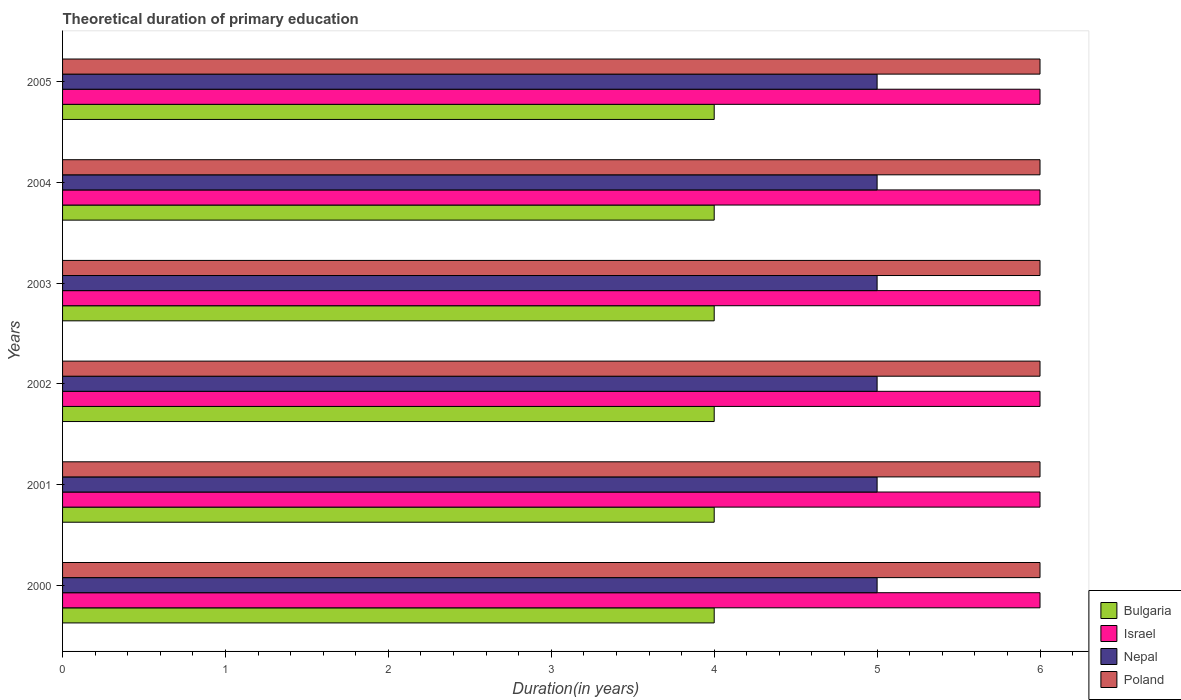How many different coloured bars are there?
Your response must be concise. 4. How many groups of bars are there?
Give a very brief answer. 6. What is the label of the 6th group of bars from the top?
Your response must be concise. 2000. In how many cases, is the number of bars for a given year not equal to the number of legend labels?
Keep it short and to the point. 0. What is the total theoretical duration of primary education in Bulgaria in 2004?
Give a very brief answer. 4. In which year was the total theoretical duration of primary education in Israel minimum?
Your response must be concise. 2000. What is the total total theoretical duration of primary education in Nepal in the graph?
Your answer should be compact. 30. What is the difference between the total theoretical duration of primary education in Israel in 2005 and the total theoretical duration of primary education in Bulgaria in 2001?
Provide a succinct answer. 2. What is the average total theoretical duration of primary education in Nepal per year?
Offer a very short reply. 5. What is the ratio of the total theoretical duration of primary education in Bulgaria in 2003 to that in 2004?
Make the answer very short. 1. Is the difference between the total theoretical duration of primary education in Poland in 2000 and 2005 greater than the difference between the total theoretical duration of primary education in Israel in 2000 and 2005?
Provide a succinct answer. No. What is the difference between the highest and the second highest total theoretical duration of primary education in Poland?
Offer a terse response. 0. What is the difference between the highest and the lowest total theoretical duration of primary education in Nepal?
Your answer should be compact. 0. In how many years, is the total theoretical duration of primary education in Nepal greater than the average total theoretical duration of primary education in Nepal taken over all years?
Your response must be concise. 0. What does the 3rd bar from the bottom in 2005 represents?
Make the answer very short. Nepal. Is it the case that in every year, the sum of the total theoretical duration of primary education in Bulgaria and total theoretical duration of primary education in Poland is greater than the total theoretical duration of primary education in Nepal?
Your answer should be very brief. Yes. Are all the bars in the graph horizontal?
Offer a very short reply. Yes. Does the graph contain any zero values?
Keep it short and to the point. No. Where does the legend appear in the graph?
Keep it short and to the point. Bottom right. How many legend labels are there?
Offer a terse response. 4. How are the legend labels stacked?
Give a very brief answer. Vertical. What is the title of the graph?
Your answer should be compact. Theoretical duration of primary education. What is the label or title of the X-axis?
Make the answer very short. Duration(in years). What is the Duration(in years) in Bulgaria in 2000?
Ensure brevity in your answer.  4. What is the Duration(in years) in Nepal in 2000?
Provide a short and direct response. 5. What is the Duration(in years) in Poland in 2001?
Offer a terse response. 6. What is the Duration(in years) of Bulgaria in 2002?
Give a very brief answer. 4. What is the Duration(in years) of Israel in 2002?
Offer a very short reply. 6. What is the Duration(in years) of Poland in 2002?
Your answer should be compact. 6. What is the Duration(in years) of Bulgaria in 2003?
Offer a terse response. 4. What is the Duration(in years) in Israel in 2003?
Offer a very short reply. 6. What is the Duration(in years) in Nepal in 2003?
Provide a short and direct response. 5. What is the Duration(in years) of Poland in 2003?
Give a very brief answer. 6. What is the Duration(in years) of Bulgaria in 2004?
Give a very brief answer. 4. What is the Duration(in years) in Poland in 2004?
Provide a short and direct response. 6. What is the Duration(in years) in Bulgaria in 2005?
Give a very brief answer. 4. What is the Duration(in years) of Israel in 2005?
Your response must be concise. 6. What is the Duration(in years) in Nepal in 2005?
Ensure brevity in your answer.  5. Across all years, what is the maximum Duration(in years) in Bulgaria?
Give a very brief answer. 4. Across all years, what is the maximum Duration(in years) in Nepal?
Make the answer very short. 5. Across all years, what is the minimum Duration(in years) of Israel?
Your answer should be compact. 6. Across all years, what is the minimum Duration(in years) of Nepal?
Your response must be concise. 5. What is the total Duration(in years) in Israel in the graph?
Keep it short and to the point. 36. What is the difference between the Duration(in years) in Bulgaria in 2000 and that in 2001?
Keep it short and to the point. 0. What is the difference between the Duration(in years) of Nepal in 2000 and that in 2001?
Offer a very short reply. 0. What is the difference between the Duration(in years) of Poland in 2000 and that in 2001?
Your response must be concise. 0. What is the difference between the Duration(in years) of Bulgaria in 2000 and that in 2002?
Ensure brevity in your answer.  0. What is the difference between the Duration(in years) in Israel in 2000 and that in 2002?
Provide a succinct answer. 0. What is the difference between the Duration(in years) of Poland in 2000 and that in 2002?
Give a very brief answer. 0. What is the difference between the Duration(in years) of Bulgaria in 2000 and that in 2003?
Make the answer very short. 0. What is the difference between the Duration(in years) of Nepal in 2000 and that in 2003?
Provide a short and direct response. 0. What is the difference between the Duration(in years) in Israel in 2000 and that in 2004?
Provide a short and direct response. 0. What is the difference between the Duration(in years) of Nepal in 2000 and that in 2004?
Give a very brief answer. 0. What is the difference between the Duration(in years) in Poland in 2001 and that in 2003?
Give a very brief answer. 0. What is the difference between the Duration(in years) in Poland in 2001 and that in 2004?
Make the answer very short. 0. What is the difference between the Duration(in years) in Israel in 2001 and that in 2005?
Your answer should be very brief. 0. What is the difference between the Duration(in years) of Nepal in 2001 and that in 2005?
Provide a short and direct response. 0. What is the difference between the Duration(in years) in Israel in 2002 and that in 2003?
Your response must be concise. 0. What is the difference between the Duration(in years) in Nepal in 2002 and that in 2003?
Make the answer very short. 0. What is the difference between the Duration(in years) of Israel in 2002 and that in 2004?
Provide a short and direct response. 0. What is the difference between the Duration(in years) of Nepal in 2002 and that in 2004?
Make the answer very short. 0. What is the difference between the Duration(in years) of Bulgaria in 2002 and that in 2005?
Provide a succinct answer. 0. What is the difference between the Duration(in years) of Israel in 2002 and that in 2005?
Offer a very short reply. 0. What is the difference between the Duration(in years) in Nepal in 2002 and that in 2005?
Provide a succinct answer. 0. What is the difference between the Duration(in years) in Poland in 2002 and that in 2005?
Provide a succinct answer. 0. What is the difference between the Duration(in years) of Bulgaria in 2003 and that in 2004?
Offer a very short reply. 0. What is the difference between the Duration(in years) of Israel in 2003 and that in 2004?
Offer a very short reply. 0. What is the difference between the Duration(in years) of Nepal in 2003 and that in 2004?
Make the answer very short. 0. What is the difference between the Duration(in years) in Poland in 2003 and that in 2005?
Offer a very short reply. 0. What is the difference between the Duration(in years) of Bulgaria in 2004 and that in 2005?
Give a very brief answer. 0. What is the difference between the Duration(in years) in Israel in 2004 and that in 2005?
Give a very brief answer. 0. What is the difference between the Duration(in years) in Poland in 2004 and that in 2005?
Offer a very short reply. 0. What is the difference between the Duration(in years) of Bulgaria in 2000 and the Duration(in years) of Poland in 2001?
Provide a succinct answer. -2. What is the difference between the Duration(in years) in Israel in 2000 and the Duration(in years) in Nepal in 2001?
Provide a succinct answer. 1. What is the difference between the Duration(in years) of Israel in 2000 and the Duration(in years) of Poland in 2001?
Your answer should be compact. 0. What is the difference between the Duration(in years) of Bulgaria in 2000 and the Duration(in years) of Nepal in 2002?
Provide a succinct answer. -1. What is the difference between the Duration(in years) of Bulgaria in 2000 and the Duration(in years) of Poland in 2002?
Provide a short and direct response. -2. What is the difference between the Duration(in years) in Israel in 2000 and the Duration(in years) in Nepal in 2002?
Provide a succinct answer. 1. What is the difference between the Duration(in years) in Bulgaria in 2000 and the Duration(in years) in Nepal in 2003?
Provide a short and direct response. -1. What is the difference between the Duration(in years) in Israel in 2000 and the Duration(in years) in Poland in 2003?
Your answer should be compact. 0. What is the difference between the Duration(in years) of Nepal in 2000 and the Duration(in years) of Poland in 2003?
Provide a succinct answer. -1. What is the difference between the Duration(in years) of Bulgaria in 2000 and the Duration(in years) of Poland in 2004?
Offer a very short reply. -2. What is the difference between the Duration(in years) in Israel in 2000 and the Duration(in years) in Nepal in 2004?
Keep it short and to the point. 1. What is the difference between the Duration(in years) in Israel in 2000 and the Duration(in years) in Poland in 2004?
Make the answer very short. 0. What is the difference between the Duration(in years) of Nepal in 2000 and the Duration(in years) of Poland in 2004?
Keep it short and to the point. -1. What is the difference between the Duration(in years) in Israel in 2000 and the Duration(in years) in Nepal in 2005?
Provide a succinct answer. 1. What is the difference between the Duration(in years) in Israel in 2000 and the Duration(in years) in Poland in 2005?
Offer a very short reply. 0. What is the difference between the Duration(in years) in Nepal in 2000 and the Duration(in years) in Poland in 2005?
Your answer should be compact. -1. What is the difference between the Duration(in years) of Bulgaria in 2001 and the Duration(in years) of Israel in 2002?
Provide a short and direct response. -2. What is the difference between the Duration(in years) of Bulgaria in 2001 and the Duration(in years) of Nepal in 2002?
Offer a very short reply. -1. What is the difference between the Duration(in years) of Israel in 2001 and the Duration(in years) of Nepal in 2002?
Offer a terse response. 1. What is the difference between the Duration(in years) in Israel in 2001 and the Duration(in years) in Poland in 2002?
Make the answer very short. 0. What is the difference between the Duration(in years) in Bulgaria in 2001 and the Duration(in years) in Nepal in 2003?
Offer a terse response. -1. What is the difference between the Duration(in years) of Israel in 2001 and the Duration(in years) of Nepal in 2003?
Provide a succinct answer. 1. What is the difference between the Duration(in years) in Israel in 2001 and the Duration(in years) in Poland in 2003?
Give a very brief answer. 0. What is the difference between the Duration(in years) of Nepal in 2001 and the Duration(in years) of Poland in 2003?
Your answer should be compact. -1. What is the difference between the Duration(in years) in Bulgaria in 2001 and the Duration(in years) in Israel in 2004?
Your response must be concise. -2. What is the difference between the Duration(in years) of Bulgaria in 2001 and the Duration(in years) of Nepal in 2004?
Provide a short and direct response. -1. What is the difference between the Duration(in years) of Bulgaria in 2001 and the Duration(in years) of Poland in 2004?
Keep it short and to the point. -2. What is the difference between the Duration(in years) of Israel in 2001 and the Duration(in years) of Poland in 2005?
Give a very brief answer. 0. What is the difference between the Duration(in years) in Nepal in 2001 and the Duration(in years) in Poland in 2005?
Offer a terse response. -1. What is the difference between the Duration(in years) in Bulgaria in 2002 and the Duration(in years) in Israel in 2003?
Give a very brief answer. -2. What is the difference between the Duration(in years) of Bulgaria in 2002 and the Duration(in years) of Nepal in 2003?
Your response must be concise. -1. What is the difference between the Duration(in years) of Bulgaria in 2002 and the Duration(in years) of Poland in 2003?
Your response must be concise. -2. What is the difference between the Duration(in years) of Israel in 2002 and the Duration(in years) of Nepal in 2003?
Offer a very short reply. 1. What is the difference between the Duration(in years) of Israel in 2002 and the Duration(in years) of Poland in 2003?
Ensure brevity in your answer.  0. What is the difference between the Duration(in years) of Bulgaria in 2002 and the Duration(in years) of Israel in 2004?
Your answer should be compact. -2. What is the difference between the Duration(in years) of Bulgaria in 2002 and the Duration(in years) of Nepal in 2004?
Make the answer very short. -1. What is the difference between the Duration(in years) of Israel in 2002 and the Duration(in years) of Nepal in 2004?
Ensure brevity in your answer.  1. What is the difference between the Duration(in years) in Bulgaria in 2002 and the Duration(in years) in Nepal in 2005?
Keep it short and to the point. -1. What is the difference between the Duration(in years) of Israel in 2002 and the Duration(in years) of Nepal in 2005?
Your answer should be compact. 1. What is the difference between the Duration(in years) of Israel in 2002 and the Duration(in years) of Poland in 2005?
Ensure brevity in your answer.  0. What is the difference between the Duration(in years) of Bulgaria in 2003 and the Duration(in years) of Nepal in 2004?
Offer a terse response. -1. What is the difference between the Duration(in years) in Bulgaria in 2003 and the Duration(in years) in Poland in 2004?
Your answer should be compact. -2. What is the difference between the Duration(in years) of Israel in 2003 and the Duration(in years) of Poland in 2004?
Ensure brevity in your answer.  0. What is the difference between the Duration(in years) in Nepal in 2003 and the Duration(in years) in Poland in 2004?
Ensure brevity in your answer.  -1. What is the difference between the Duration(in years) of Bulgaria in 2003 and the Duration(in years) of Israel in 2005?
Make the answer very short. -2. What is the difference between the Duration(in years) of Bulgaria in 2003 and the Duration(in years) of Poland in 2005?
Keep it short and to the point. -2. What is the difference between the Duration(in years) of Israel in 2003 and the Duration(in years) of Poland in 2005?
Offer a very short reply. 0. What is the difference between the Duration(in years) in Bulgaria in 2004 and the Duration(in years) in Poland in 2005?
Your response must be concise. -2. What is the difference between the Duration(in years) in Israel in 2004 and the Duration(in years) in Nepal in 2005?
Offer a terse response. 1. What is the average Duration(in years) of Israel per year?
Keep it short and to the point. 6. In the year 2000, what is the difference between the Duration(in years) of Israel and Duration(in years) of Poland?
Keep it short and to the point. 0. In the year 2000, what is the difference between the Duration(in years) of Nepal and Duration(in years) of Poland?
Offer a terse response. -1. In the year 2001, what is the difference between the Duration(in years) of Bulgaria and Duration(in years) of Israel?
Make the answer very short. -2. In the year 2001, what is the difference between the Duration(in years) of Israel and Duration(in years) of Nepal?
Provide a succinct answer. 1. In the year 2002, what is the difference between the Duration(in years) of Bulgaria and Duration(in years) of Israel?
Your answer should be compact. -2. In the year 2002, what is the difference between the Duration(in years) in Bulgaria and Duration(in years) in Poland?
Make the answer very short. -2. In the year 2002, what is the difference between the Duration(in years) in Israel and Duration(in years) in Poland?
Offer a very short reply. 0. In the year 2002, what is the difference between the Duration(in years) of Nepal and Duration(in years) of Poland?
Your response must be concise. -1. In the year 2003, what is the difference between the Duration(in years) of Israel and Duration(in years) of Nepal?
Keep it short and to the point. 1. In the year 2003, what is the difference between the Duration(in years) of Nepal and Duration(in years) of Poland?
Make the answer very short. -1. In the year 2004, what is the difference between the Duration(in years) in Bulgaria and Duration(in years) in Israel?
Give a very brief answer. -2. In the year 2004, what is the difference between the Duration(in years) in Bulgaria and Duration(in years) in Nepal?
Your response must be concise. -1. In the year 2004, what is the difference between the Duration(in years) in Bulgaria and Duration(in years) in Poland?
Your response must be concise. -2. In the year 2004, what is the difference between the Duration(in years) in Israel and Duration(in years) in Nepal?
Your answer should be compact. 1. In the year 2004, what is the difference between the Duration(in years) of Nepal and Duration(in years) of Poland?
Give a very brief answer. -1. In the year 2005, what is the difference between the Duration(in years) in Bulgaria and Duration(in years) in Poland?
Your answer should be very brief. -2. In the year 2005, what is the difference between the Duration(in years) of Israel and Duration(in years) of Nepal?
Give a very brief answer. 1. In the year 2005, what is the difference between the Duration(in years) of Israel and Duration(in years) of Poland?
Provide a succinct answer. 0. What is the ratio of the Duration(in years) of Israel in 2000 to that in 2001?
Offer a very short reply. 1. What is the ratio of the Duration(in years) of Bulgaria in 2000 to that in 2002?
Offer a terse response. 1. What is the ratio of the Duration(in years) of Israel in 2000 to that in 2002?
Your response must be concise. 1. What is the ratio of the Duration(in years) of Nepal in 2000 to that in 2002?
Provide a short and direct response. 1. What is the ratio of the Duration(in years) of Poland in 2000 to that in 2002?
Your answer should be very brief. 1. What is the ratio of the Duration(in years) of Bulgaria in 2000 to that in 2003?
Your answer should be compact. 1. What is the ratio of the Duration(in years) in Bulgaria in 2000 to that in 2004?
Your answer should be compact. 1. What is the ratio of the Duration(in years) of Bulgaria in 2000 to that in 2005?
Offer a very short reply. 1. What is the ratio of the Duration(in years) in Israel in 2000 to that in 2005?
Provide a succinct answer. 1. What is the ratio of the Duration(in years) in Nepal in 2000 to that in 2005?
Give a very brief answer. 1. What is the ratio of the Duration(in years) of Israel in 2001 to that in 2002?
Provide a succinct answer. 1. What is the ratio of the Duration(in years) in Poland in 2001 to that in 2002?
Ensure brevity in your answer.  1. What is the ratio of the Duration(in years) in Israel in 2001 to that in 2003?
Give a very brief answer. 1. What is the ratio of the Duration(in years) in Bulgaria in 2001 to that in 2004?
Your answer should be very brief. 1. What is the ratio of the Duration(in years) in Poland in 2001 to that in 2004?
Keep it short and to the point. 1. What is the ratio of the Duration(in years) in Poland in 2001 to that in 2005?
Give a very brief answer. 1. What is the ratio of the Duration(in years) in Poland in 2002 to that in 2003?
Offer a very short reply. 1. What is the ratio of the Duration(in years) of Israel in 2002 to that in 2004?
Keep it short and to the point. 1. What is the ratio of the Duration(in years) in Nepal in 2002 to that in 2004?
Provide a succinct answer. 1. What is the ratio of the Duration(in years) of Poland in 2002 to that in 2004?
Give a very brief answer. 1. What is the ratio of the Duration(in years) of Nepal in 2002 to that in 2005?
Your answer should be very brief. 1. What is the ratio of the Duration(in years) in Poland in 2003 to that in 2004?
Give a very brief answer. 1. What is the ratio of the Duration(in years) of Israel in 2003 to that in 2005?
Your answer should be compact. 1. What is the ratio of the Duration(in years) in Israel in 2004 to that in 2005?
Make the answer very short. 1. What is the difference between the highest and the second highest Duration(in years) in Bulgaria?
Provide a succinct answer. 0. What is the difference between the highest and the second highest Duration(in years) in Poland?
Your answer should be compact. 0. What is the difference between the highest and the lowest Duration(in years) of Bulgaria?
Provide a succinct answer. 0. What is the difference between the highest and the lowest Duration(in years) of Poland?
Provide a succinct answer. 0. 